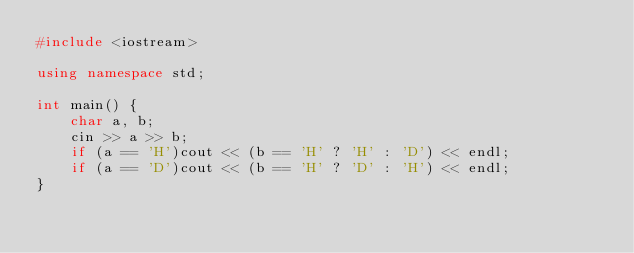Convert code to text. <code><loc_0><loc_0><loc_500><loc_500><_C++_>#include <iostream>

using namespace std;

int main() {
    char a, b;
    cin >> a >> b;
    if (a == 'H')cout << (b == 'H' ? 'H' : 'D') << endl;
    if (a == 'D')cout << (b == 'H' ? 'D' : 'H') << endl;
}</code> 